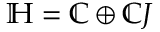Convert formula to latex. <formula><loc_0><loc_0><loc_500><loc_500>\mathbb { H } = \mathbb { C } \oplus \mathbb { C } J</formula> 